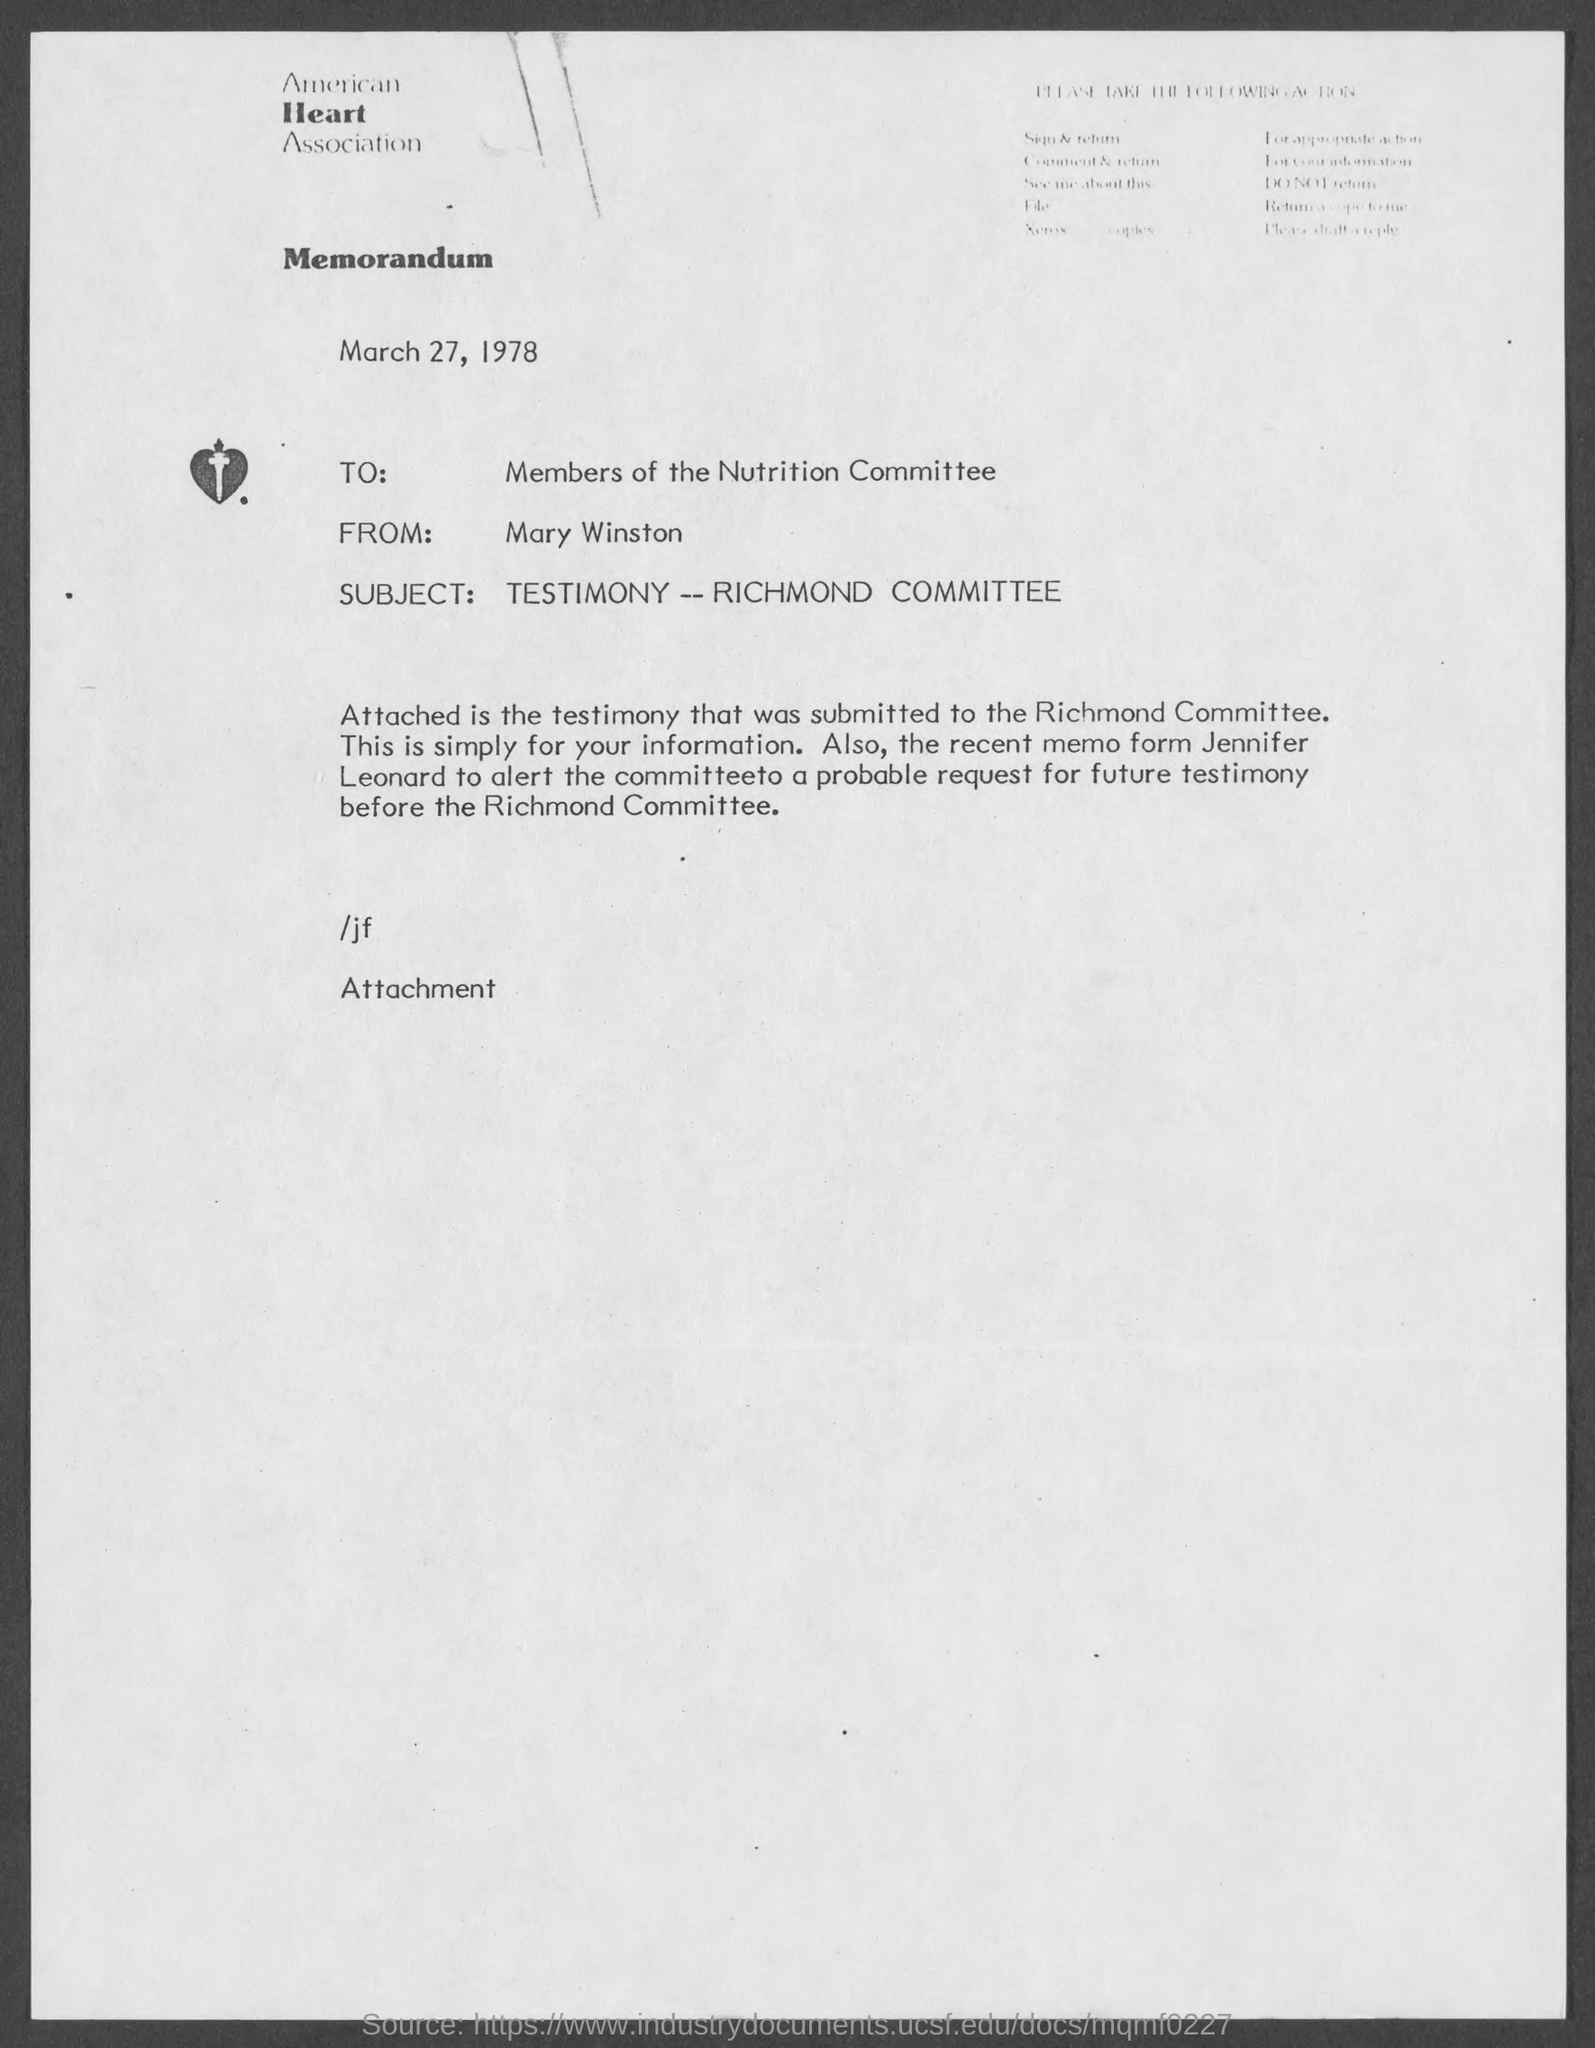Point out several critical features in this image. The document is dated March 27, 1978. The letter is addressed to the members of the Nutrition Committee. The letter is from Mary Winston. The subject of the letter is testimony regarding the Richmond Committee. 